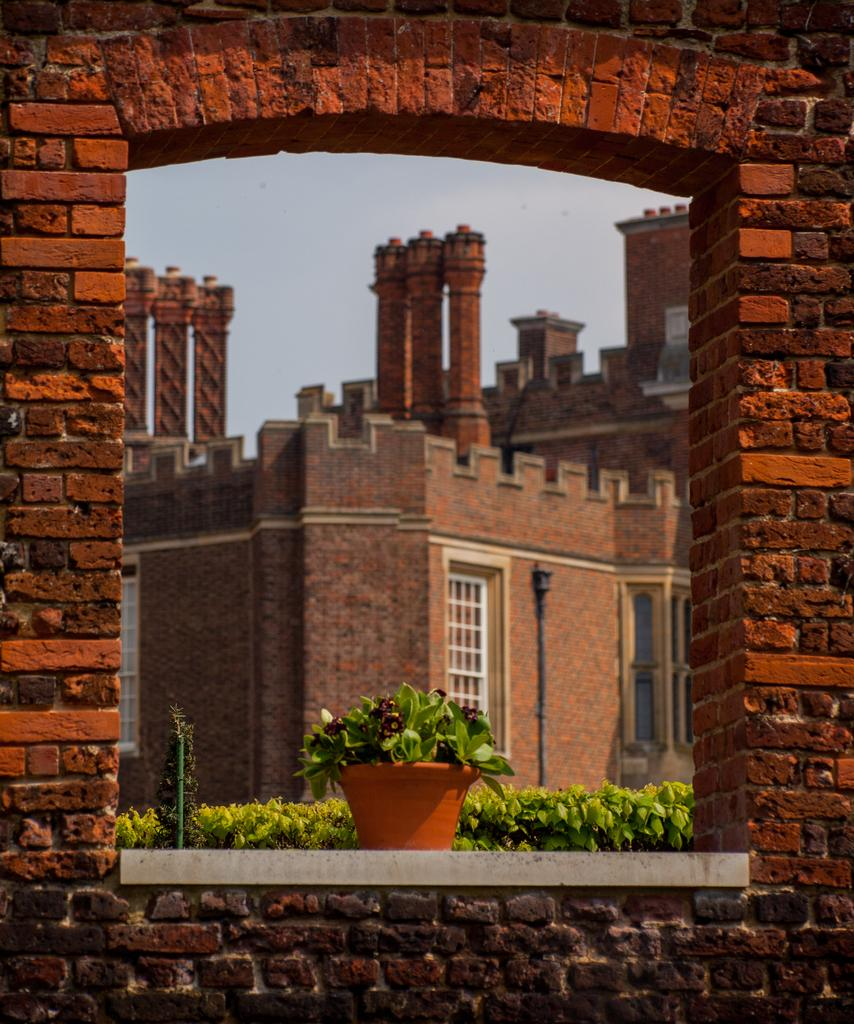What type of structure is visible in the image? There is a brick wall in the image. What type of plant can be seen in the image? There is a flower plant with a pot in the image. What can be seen in the background of the image? The background of the image includes many plants, a pole, a house, walls, windows, a pipe, and pillars. The sky is also visible in the background. Can you see a boat floating in the sky in the image? No, there is no boat visible in the image. The sky is visible in the background, but there is no boat present. 